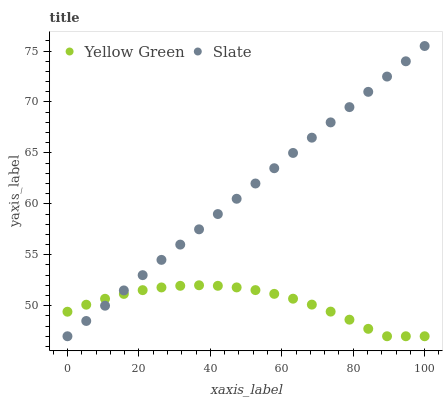Does Yellow Green have the minimum area under the curve?
Answer yes or no. Yes. Does Slate have the maximum area under the curve?
Answer yes or no. Yes. Does Yellow Green have the maximum area under the curve?
Answer yes or no. No. Is Slate the smoothest?
Answer yes or no. Yes. Is Yellow Green the roughest?
Answer yes or no. Yes. Is Yellow Green the smoothest?
Answer yes or no. No. Does Slate have the lowest value?
Answer yes or no. Yes. Does Slate have the highest value?
Answer yes or no. Yes. Does Yellow Green have the highest value?
Answer yes or no. No. Does Slate intersect Yellow Green?
Answer yes or no. Yes. Is Slate less than Yellow Green?
Answer yes or no. No. Is Slate greater than Yellow Green?
Answer yes or no. No. 